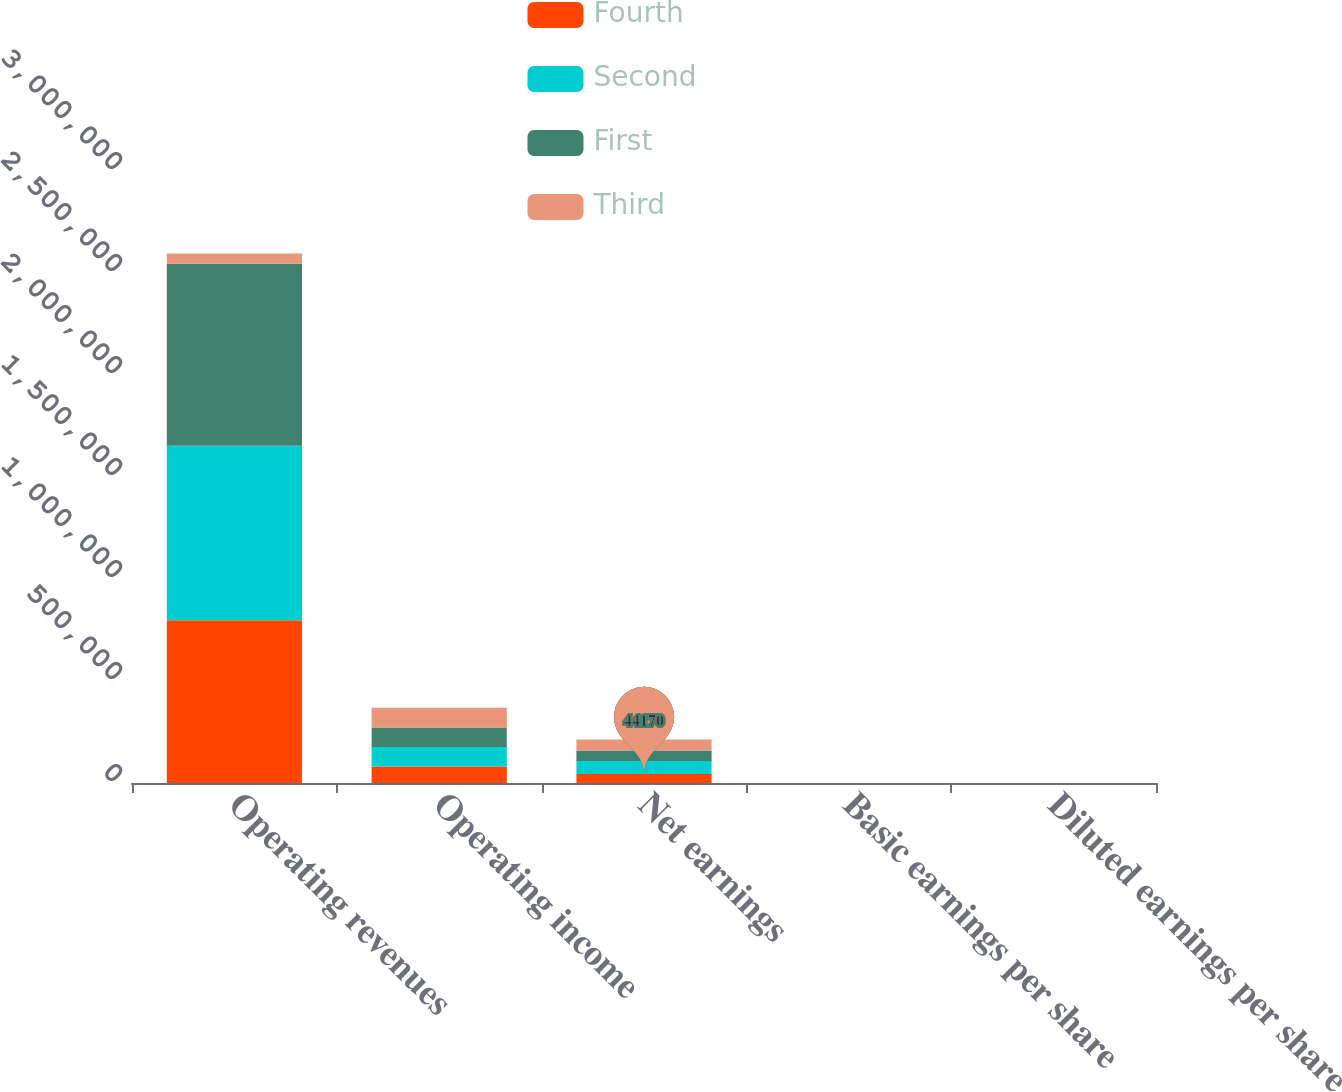Convert chart to OTSL. <chart><loc_0><loc_0><loc_500><loc_500><stacked_bar_chart><ecel><fcel>Operating revenues<fcel>Operating income<fcel>Net earnings<fcel>Basic earnings per share<fcel>Diluted earnings per share<nl><fcel>Fourth<fcel>797451<fcel>80399<fcel>44170<fcel>0.31<fcel>0.3<nl><fcel>Second<fcel>855860<fcel>96227<fcel>63857<fcel>0.46<fcel>0.45<nl><fcel>First<fcel>891638<fcel>95899<fcel>50783<fcel>0.39<fcel>0.38<nl><fcel>Third<fcel>50783<fcel>96265<fcel>54323<fcel>0.43<fcel>0.42<nl></chart> 